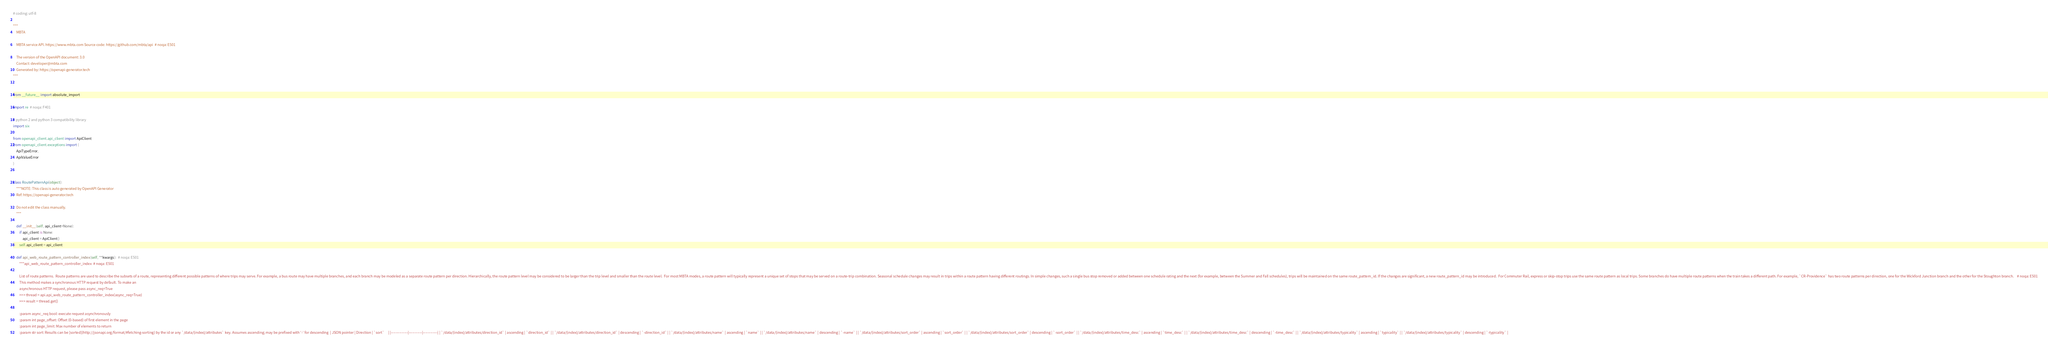Convert code to text. <code><loc_0><loc_0><loc_500><loc_500><_Python_># coding: utf-8

"""
    MBTA

    MBTA service API. https://www.mbta.com Source code: https://github.com/mbta/api  # noqa: E501

    The version of the OpenAPI document: 3.0
    Contact: developer@mbta.com
    Generated by: https://openapi-generator.tech
"""


from __future__ import absolute_import

import re  # noqa: F401

# python 2 and python 3 compatibility library
import six

from openapi_client.api_client import ApiClient
from openapi_client.exceptions import (
    ApiTypeError,
    ApiValueError
)


class RoutePatternApi(object):
    """NOTE: This class is auto generated by OpenAPI Generator
    Ref: https://openapi-generator.tech

    Do not edit the class manually.
    """

    def __init__(self, api_client=None):
        if api_client is None:
            api_client = ApiClient()
        self.api_client = api_client

    def api_web_route_pattern_controller_index(self, **kwargs):  # noqa: E501
        """api_web_route_pattern_controller_index  # noqa: E501

        List of route patterns.  Route patterns are used to describe the subsets of a route, representing different possible patterns of where trips may serve. For example, a bus route may have multiple branches, and each branch may be modeled as a separate route pattern per direction. Hierarchically, the route pattern level may be considered to be larger than the trip level and smaller than the route level.  For most MBTA modes, a route pattern will typically represent a unique set of stops that may be served on a route-trip combination. Seasonal schedule changes may result in trips within a route pattern having different routings. In simple changes, such a single bus stop removed or added between one schedule rating and the next (for example, between the Summer and Fall schedules), trips will be maintained on the same route_pattern_id. If the changes are significant, a new route_pattern_id may be introduced.  For Commuter Rail, express or skip-stop trips use the same route pattern as local trips. Some branches do have multiple route patterns when the train takes a different path. For example, `CR-Providence` has two route patterns per direction, one for the Wickford Junction branch and the other for the Stoughton branch.    # noqa: E501
        This method makes a synchronous HTTP request by default. To make an
        asynchronous HTTP request, please pass async_req=True
        >>> thread = api.api_web_route_pattern_controller_index(async_req=True)
        >>> result = thread.get()

        :param async_req bool: execute request asynchronously
        :param int page_offset: Offset (0-based) of first element in the page
        :param int page_limit: Max number of elements to return
        :param str sort: Results can be [sorted](http://jsonapi.org/format/#fetching-sorting) by the id or any `/data/{index}/attributes` key. Assumes ascending; may be prefixed with '-' for descending  | JSON pointer | Direction | `sort`     | |--------------|-----------|------------| | `/data/{index}/attributes/direction_id` | ascending | `direction_id` | | `/data/{index}/attributes/direction_id` | descending | `-direction_id` | | `/data/{index}/attributes/name` | ascending | `name` | | `/data/{index}/attributes/name` | descending | `-name` | | `/data/{index}/attributes/sort_order` | ascending | `sort_order` | | `/data/{index}/attributes/sort_order` | descending | `-sort_order` | | `/data/{index}/attributes/time_desc` | ascending | `time_desc` | | `/data/{index}/attributes/time_desc` | descending | `-time_desc` | | `/data/{index}/attributes/typicality` | ascending | `typicality` | | `/data/{index}/attributes/typicality` | descending | `-typicality` |  </code> 